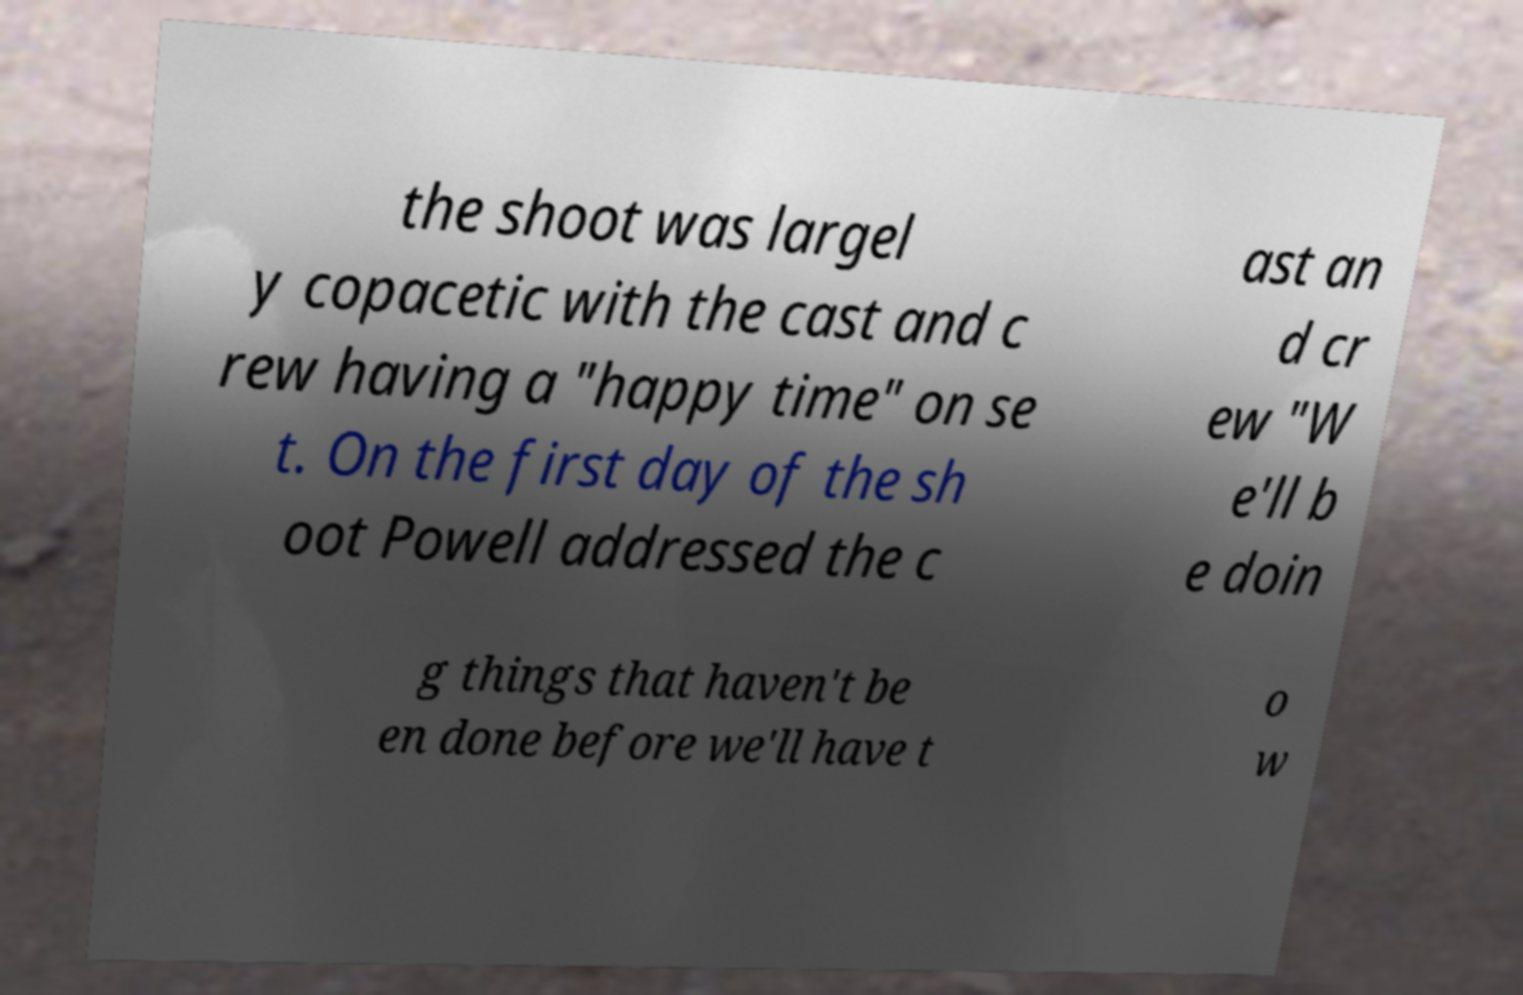For documentation purposes, I need the text within this image transcribed. Could you provide that? the shoot was largel y copacetic with the cast and c rew having a "happy time" on se t. On the first day of the sh oot Powell addressed the c ast an d cr ew "W e'll b e doin g things that haven't be en done before we'll have t o w 